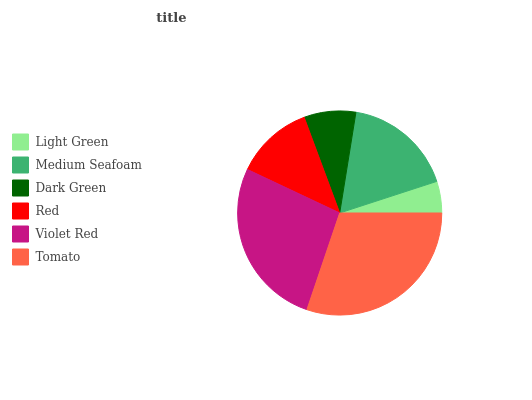Is Light Green the minimum?
Answer yes or no. Yes. Is Tomato the maximum?
Answer yes or no. Yes. Is Medium Seafoam the minimum?
Answer yes or no. No. Is Medium Seafoam the maximum?
Answer yes or no. No. Is Medium Seafoam greater than Light Green?
Answer yes or no. Yes. Is Light Green less than Medium Seafoam?
Answer yes or no. Yes. Is Light Green greater than Medium Seafoam?
Answer yes or no. No. Is Medium Seafoam less than Light Green?
Answer yes or no. No. Is Medium Seafoam the high median?
Answer yes or no. Yes. Is Red the low median?
Answer yes or no. Yes. Is Violet Red the high median?
Answer yes or no. No. Is Medium Seafoam the low median?
Answer yes or no. No. 